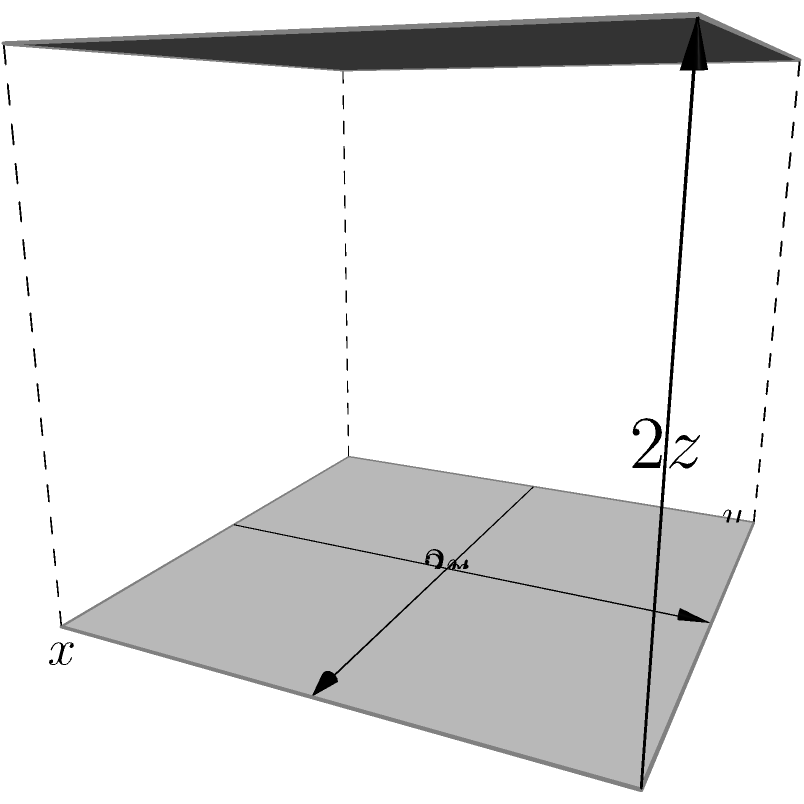As a postgraduate student working on optimization problems, you encounter the following scenario:

A rectangular box with an open top needs to be constructed from a sheet of material with a fixed surface area of 108 square units. The box's base length is twice its width. Find the dimensions of the box that will maximize its volume.

Given:
- Total surface area (including base and four sides, excluding top) = 108 square units
- Base length = $2x$
- Base width = $y$
- Height = $z$

Determine the values of $x$, $y$, and $z$ that maximize the volume of the box. Let's approach this step-by-step:

1) Express the surface area in terms of $x$, $y$, and $z$:
   Surface area = $2xy + 2xz + 2yz = 108$
   Given that $y = x$, we can substitute:
   $2x^2 + 2xz + 2xz = 108$
   $2x^2 + 4xz = 108$ ... (1)

2) Express the volume in terms of $x$ and $z$:
   $V = 2x \cdot x \cdot z = 2x^2z$ ... (2)

3) From equation (1), solve for $z$:
   $4xz = 108 - 2x^2$
   $z = \frac{108 - 2x^2}{4x}$ ... (3)

4) Substitute (3) into (2):
   $V = 2x^2 \cdot \frac{108 - 2x^2}{4x} = \frac{x(108 - 2x^2)}{2}$

5) To find the maximum volume, differentiate $V$ with respect to $x$ and set it to zero:
   $\frac{dV}{dx} = \frac{108 - 2x^2}{2} - \frac{2x^2}{2} = 0$
   $108 - 2x^2 - 2x^2 = 0$
   $108 - 4x^2 = 0$
   $4x^2 = 108$
   $x^2 = 27$
   $x = 3\sqrt{3}$

6) Calculate $y$ and $z$:
   $y = x = 3\sqrt{3}$
   $z = \frac{108 - 2(3\sqrt{3})^2}{4(3\sqrt{3})} = \frac{108 - 54}{12\sqrt{3}} = \frac{9}{2\sqrt{3}}$

Therefore, the dimensions that maximize the volume are:
$x = 3\sqrt{3}$, $y = 3\sqrt{3}$, and $z = \frac{9}{2\sqrt{3}}$.
Answer: $x = y = 3\sqrt{3}$, $z = \frac{9}{2\sqrt{3}}$ 